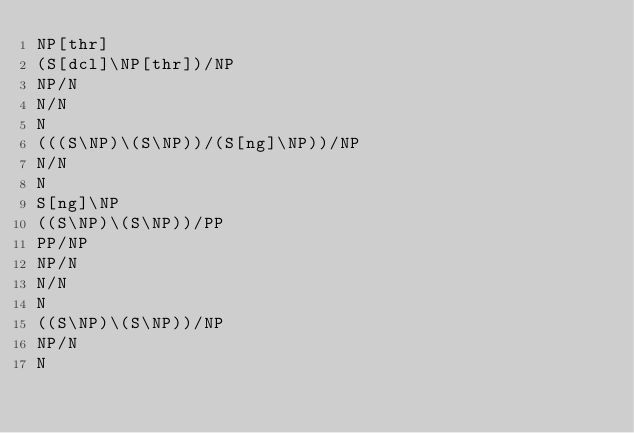Convert code to text. <code><loc_0><loc_0><loc_500><loc_500><_C_>NP[thr]
(S[dcl]\NP[thr])/NP
NP/N
N/N
N
(((S\NP)\(S\NP))/(S[ng]\NP))/NP
N/N
N
S[ng]\NP
((S\NP)\(S\NP))/PP
PP/NP
NP/N
N/N
N
((S\NP)\(S\NP))/NP
NP/N
N
</code> 